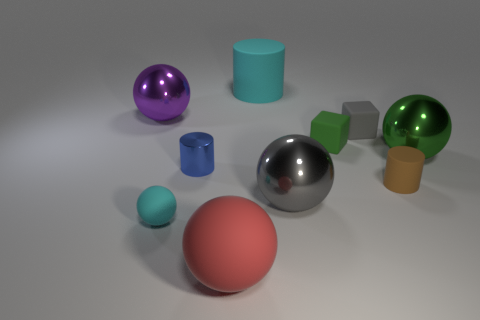Subtract all cyan rubber spheres. How many spheres are left? 4 Subtract all cyan balls. How many balls are left? 4 Subtract all green spheres. Subtract all gray cylinders. How many spheres are left? 4 Subtract all cylinders. How many objects are left? 7 Subtract all small gray rubber blocks. Subtract all big red objects. How many objects are left? 8 Add 6 tiny cyan balls. How many tiny cyan balls are left? 7 Add 5 tiny things. How many tiny things exist? 10 Subtract 1 blue cylinders. How many objects are left? 9 